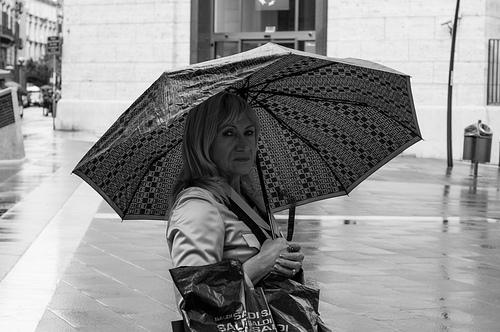Question: who is holding the umbrella?
Choices:
A. Woman.
B. Man.
C. Child.
D. Elderly woman.
Answer with the letter. Answer: A Question: why is it raining?
Choices:
A. Weather.
B. Rain clouds.
C. Mother nature said so.
D. Cold out.
Answer with the letter. Answer: A Question: what is black?
Choices:
A. Her shoes.
B. Her belt.
C. The bag on her arm.
D. Her hat.
Answer with the letter. Answer: C Question: what is patterned?
Choices:
A. Skirt.
B. Umbrella.
C. Coat.
D. Shoes.
Answer with the letter. Answer: B Question: where is she standing?
Choices:
A. At a bus stop.
B. Sidewalk.
C. Outside a taxi.
D. In a doorway.
Answer with the letter. Answer: B 